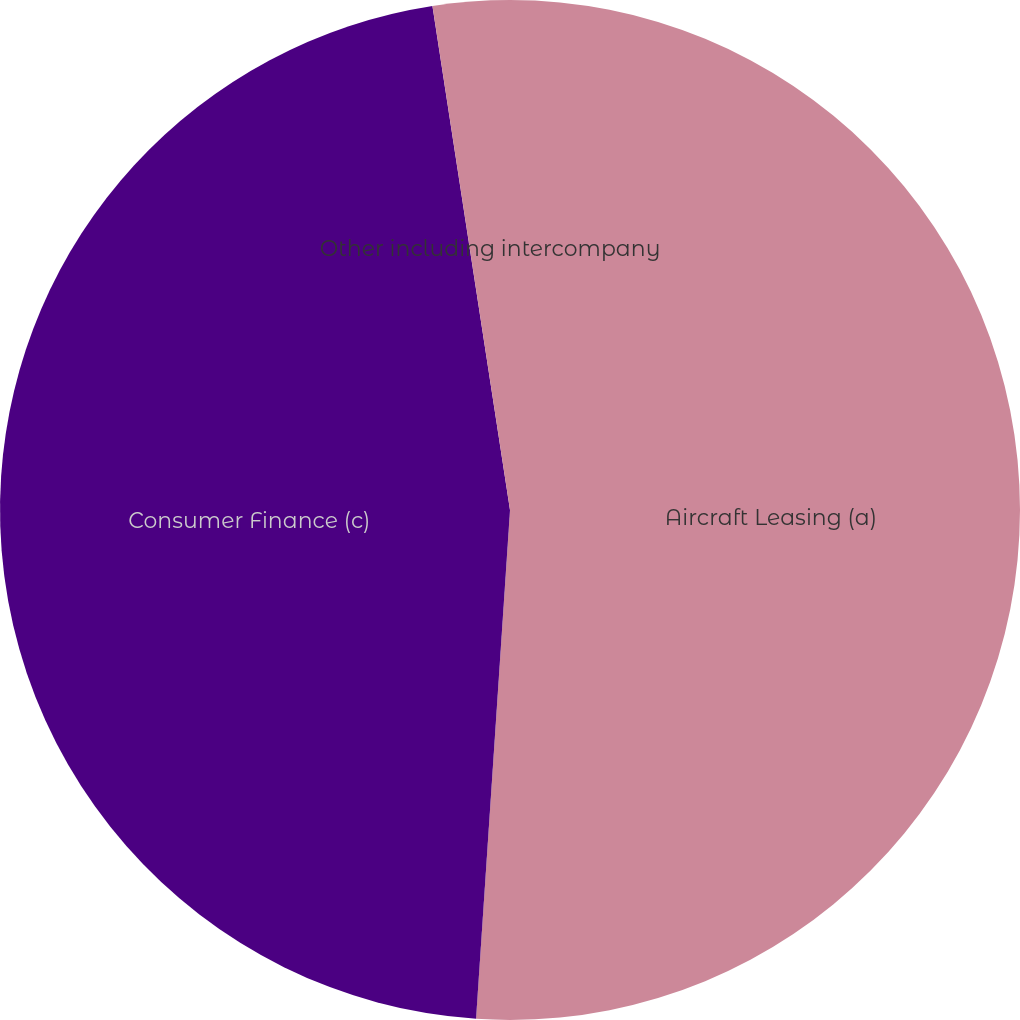Convert chart to OTSL. <chart><loc_0><loc_0><loc_500><loc_500><pie_chart><fcel>Aircraft Leasing (a)<fcel>Consumer Finance (c)<fcel>Other including intercompany<nl><fcel>51.06%<fcel>46.51%<fcel>2.43%<nl></chart> 